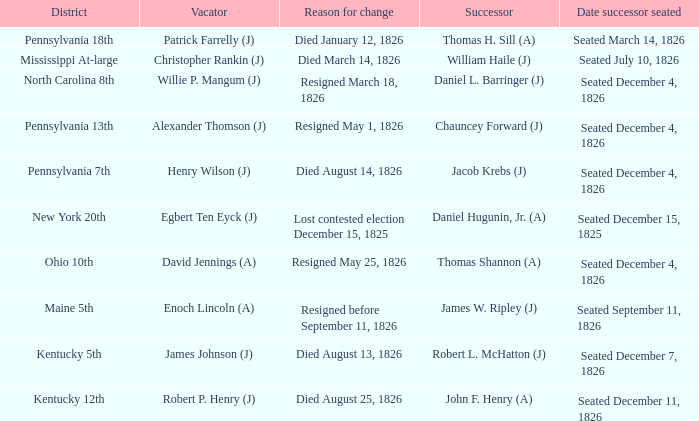Name the vacator for reason for change died january 12, 1826 Patrick Farrelly (J). 